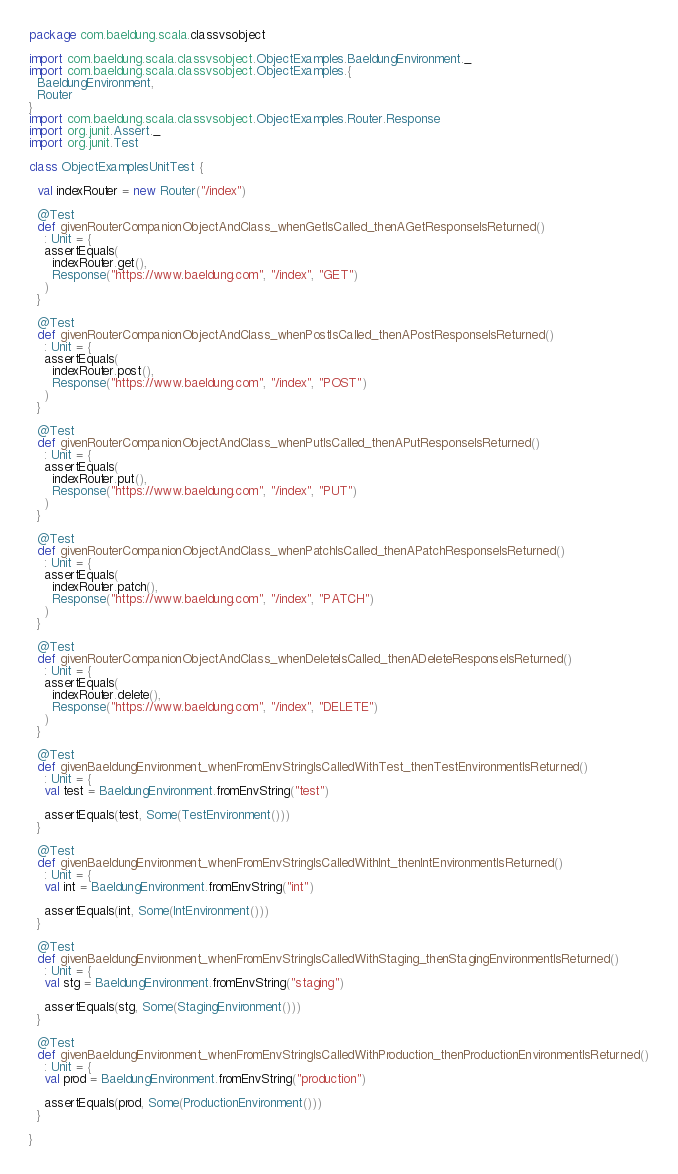<code> <loc_0><loc_0><loc_500><loc_500><_Scala_>package com.baeldung.scala.classvsobject

import com.baeldung.scala.classvsobject.ObjectExamples.BaeldungEnvironment._
import com.baeldung.scala.classvsobject.ObjectExamples.{
  BaeldungEnvironment,
  Router
}
import com.baeldung.scala.classvsobject.ObjectExamples.Router.Response
import org.junit.Assert._
import org.junit.Test

class ObjectExamplesUnitTest {

  val indexRouter = new Router("/index")

  @Test
  def givenRouterCompanionObjectAndClass_whenGetIsCalled_thenAGetResponseIsReturned()
    : Unit = {
    assertEquals(
      indexRouter.get(),
      Response("https://www.baeldung.com", "/index", "GET")
    )
  }

  @Test
  def givenRouterCompanionObjectAndClass_whenPostIsCalled_thenAPostResponseIsReturned()
    : Unit = {
    assertEquals(
      indexRouter.post(),
      Response("https://www.baeldung.com", "/index", "POST")
    )
  }

  @Test
  def givenRouterCompanionObjectAndClass_whenPutIsCalled_thenAPutResponseIsReturned()
    : Unit = {
    assertEquals(
      indexRouter.put(),
      Response("https://www.baeldung.com", "/index", "PUT")
    )
  }

  @Test
  def givenRouterCompanionObjectAndClass_whenPatchIsCalled_thenAPatchResponseIsReturned()
    : Unit = {
    assertEquals(
      indexRouter.patch(),
      Response("https://www.baeldung.com", "/index", "PATCH")
    )
  }

  @Test
  def givenRouterCompanionObjectAndClass_whenDeleteIsCalled_thenADeleteResponseIsReturned()
    : Unit = {
    assertEquals(
      indexRouter.delete(),
      Response("https://www.baeldung.com", "/index", "DELETE")
    )
  }

  @Test
  def givenBaeldungEnvironment_whenFromEnvStringIsCalledWithTest_thenTestEnvironmentIsReturned()
    : Unit = {
    val test = BaeldungEnvironment.fromEnvString("test")

    assertEquals(test, Some(TestEnvironment()))
  }

  @Test
  def givenBaeldungEnvironment_whenFromEnvStringIsCalledWithInt_thenIntEnvironmentIsReturned()
    : Unit = {
    val int = BaeldungEnvironment.fromEnvString("int")

    assertEquals(int, Some(IntEnvironment()))
  }

  @Test
  def givenBaeldungEnvironment_whenFromEnvStringIsCalledWithStaging_thenStagingEnvironmentIsReturned()
    : Unit = {
    val stg = BaeldungEnvironment.fromEnvString("staging")

    assertEquals(stg, Some(StagingEnvironment()))
  }

  @Test
  def givenBaeldungEnvironment_whenFromEnvStringIsCalledWithProduction_thenProductionEnvironmentIsReturned()
    : Unit = {
    val prod = BaeldungEnvironment.fromEnvString("production")

    assertEquals(prod, Some(ProductionEnvironment()))
  }

}
</code> 